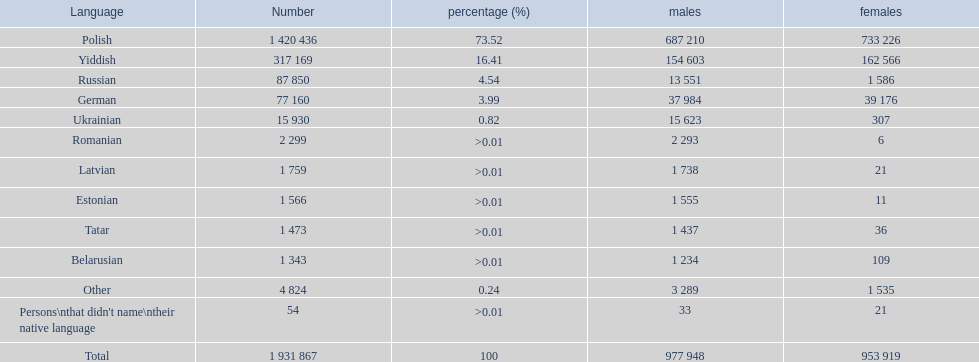Which language had the least female speakers? Romanian. 